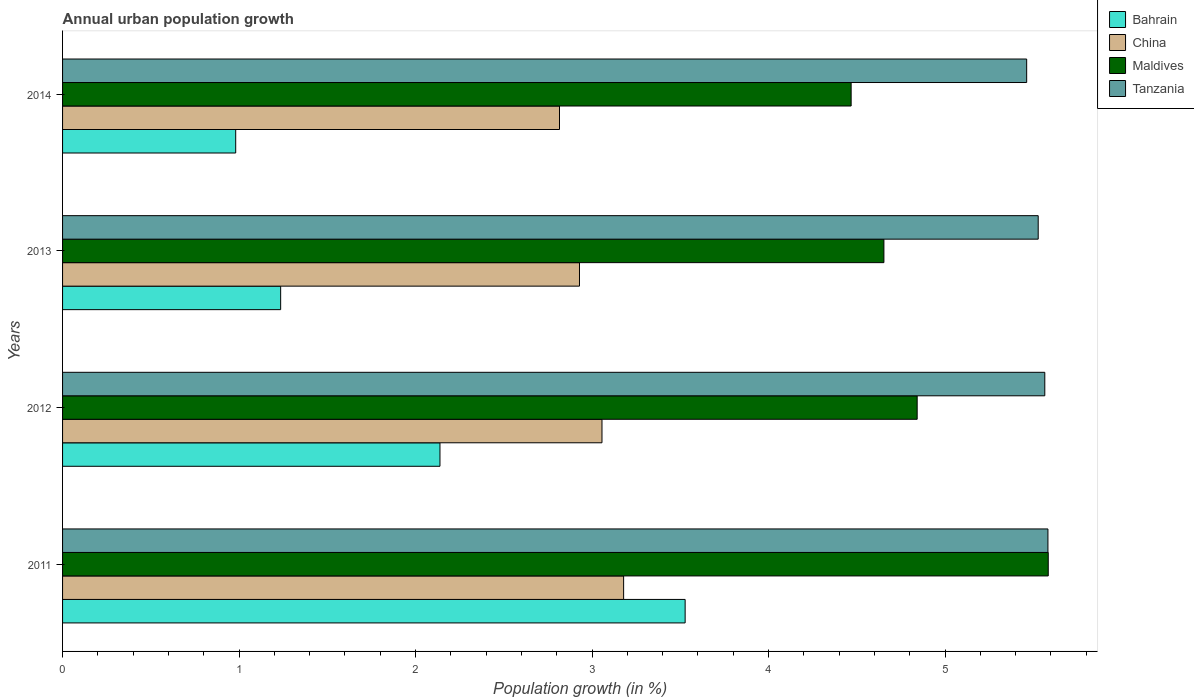Are the number of bars per tick equal to the number of legend labels?
Make the answer very short. Yes. How many bars are there on the 2nd tick from the top?
Ensure brevity in your answer.  4. In how many cases, is the number of bars for a given year not equal to the number of legend labels?
Provide a succinct answer. 0. What is the percentage of urban population growth in Tanzania in 2011?
Offer a terse response. 5.58. Across all years, what is the maximum percentage of urban population growth in Bahrain?
Make the answer very short. 3.53. Across all years, what is the minimum percentage of urban population growth in China?
Your response must be concise. 2.82. In which year was the percentage of urban population growth in Maldives maximum?
Offer a very short reply. 2011. In which year was the percentage of urban population growth in Bahrain minimum?
Provide a succinct answer. 2014. What is the total percentage of urban population growth in Bahrain in the graph?
Your answer should be compact. 7.88. What is the difference between the percentage of urban population growth in Maldives in 2013 and that in 2014?
Offer a very short reply. 0.19. What is the difference between the percentage of urban population growth in Tanzania in 2011 and the percentage of urban population growth in China in 2012?
Ensure brevity in your answer.  2.53. What is the average percentage of urban population growth in China per year?
Your answer should be compact. 2.99. In the year 2014, what is the difference between the percentage of urban population growth in Bahrain and percentage of urban population growth in Maldives?
Keep it short and to the point. -3.49. What is the ratio of the percentage of urban population growth in Maldives in 2013 to that in 2014?
Your answer should be very brief. 1.04. Is the percentage of urban population growth in Bahrain in 2013 less than that in 2014?
Your answer should be very brief. No. What is the difference between the highest and the second highest percentage of urban population growth in China?
Ensure brevity in your answer.  0.12. What is the difference between the highest and the lowest percentage of urban population growth in China?
Provide a succinct answer. 0.36. Is the sum of the percentage of urban population growth in China in 2013 and 2014 greater than the maximum percentage of urban population growth in Bahrain across all years?
Your response must be concise. Yes. What does the 2nd bar from the top in 2012 represents?
Your response must be concise. Maldives. What does the 3rd bar from the bottom in 2011 represents?
Provide a short and direct response. Maldives. How many years are there in the graph?
Keep it short and to the point. 4. What is the difference between two consecutive major ticks on the X-axis?
Your answer should be very brief. 1. Are the values on the major ticks of X-axis written in scientific E-notation?
Provide a succinct answer. No. Does the graph contain grids?
Your answer should be compact. No. Where does the legend appear in the graph?
Offer a very short reply. Top right. How are the legend labels stacked?
Ensure brevity in your answer.  Vertical. What is the title of the graph?
Make the answer very short. Annual urban population growth. Does "Caribbean small states" appear as one of the legend labels in the graph?
Offer a very short reply. No. What is the label or title of the X-axis?
Offer a terse response. Population growth (in %). What is the label or title of the Y-axis?
Your answer should be compact. Years. What is the Population growth (in %) in Bahrain in 2011?
Keep it short and to the point. 3.53. What is the Population growth (in %) in China in 2011?
Keep it short and to the point. 3.18. What is the Population growth (in %) of Maldives in 2011?
Give a very brief answer. 5.58. What is the Population growth (in %) of Tanzania in 2011?
Provide a short and direct response. 5.58. What is the Population growth (in %) of Bahrain in 2012?
Make the answer very short. 2.14. What is the Population growth (in %) in China in 2012?
Provide a succinct answer. 3.06. What is the Population growth (in %) of Maldives in 2012?
Provide a succinct answer. 4.84. What is the Population growth (in %) of Tanzania in 2012?
Your answer should be very brief. 5.56. What is the Population growth (in %) of Bahrain in 2013?
Your response must be concise. 1.24. What is the Population growth (in %) of China in 2013?
Offer a terse response. 2.93. What is the Population growth (in %) of Maldives in 2013?
Ensure brevity in your answer.  4.65. What is the Population growth (in %) in Tanzania in 2013?
Make the answer very short. 5.53. What is the Population growth (in %) in Bahrain in 2014?
Your response must be concise. 0.98. What is the Population growth (in %) in China in 2014?
Your response must be concise. 2.82. What is the Population growth (in %) in Maldives in 2014?
Ensure brevity in your answer.  4.47. What is the Population growth (in %) in Tanzania in 2014?
Make the answer very short. 5.46. Across all years, what is the maximum Population growth (in %) of Bahrain?
Your answer should be compact. 3.53. Across all years, what is the maximum Population growth (in %) in China?
Your answer should be compact. 3.18. Across all years, what is the maximum Population growth (in %) of Maldives?
Make the answer very short. 5.58. Across all years, what is the maximum Population growth (in %) of Tanzania?
Your answer should be very brief. 5.58. Across all years, what is the minimum Population growth (in %) of Bahrain?
Ensure brevity in your answer.  0.98. Across all years, what is the minimum Population growth (in %) in China?
Offer a terse response. 2.82. Across all years, what is the minimum Population growth (in %) of Maldives?
Provide a short and direct response. 4.47. Across all years, what is the minimum Population growth (in %) in Tanzania?
Ensure brevity in your answer.  5.46. What is the total Population growth (in %) in Bahrain in the graph?
Your answer should be very brief. 7.88. What is the total Population growth (in %) of China in the graph?
Your answer should be compact. 11.98. What is the total Population growth (in %) of Maldives in the graph?
Provide a short and direct response. 19.55. What is the total Population growth (in %) of Tanzania in the graph?
Provide a succinct answer. 22.14. What is the difference between the Population growth (in %) of Bahrain in 2011 and that in 2012?
Offer a terse response. 1.39. What is the difference between the Population growth (in %) in China in 2011 and that in 2012?
Provide a succinct answer. 0.12. What is the difference between the Population growth (in %) of Maldives in 2011 and that in 2012?
Your response must be concise. 0.74. What is the difference between the Population growth (in %) in Tanzania in 2011 and that in 2012?
Provide a short and direct response. 0.02. What is the difference between the Population growth (in %) in Bahrain in 2011 and that in 2013?
Provide a short and direct response. 2.29. What is the difference between the Population growth (in %) of Maldives in 2011 and that in 2013?
Your answer should be compact. 0.93. What is the difference between the Population growth (in %) in Tanzania in 2011 and that in 2013?
Your response must be concise. 0.06. What is the difference between the Population growth (in %) of Bahrain in 2011 and that in 2014?
Provide a short and direct response. 2.55. What is the difference between the Population growth (in %) of China in 2011 and that in 2014?
Offer a very short reply. 0.36. What is the difference between the Population growth (in %) of Maldives in 2011 and that in 2014?
Keep it short and to the point. 1.12. What is the difference between the Population growth (in %) of Tanzania in 2011 and that in 2014?
Provide a short and direct response. 0.12. What is the difference between the Population growth (in %) of Bahrain in 2012 and that in 2013?
Your answer should be compact. 0.9. What is the difference between the Population growth (in %) of China in 2012 and that in 2013?
Offer a very short reply. 0.13. What is the difference between the Population growth (in %) in Maldives in 2012 and that in 2013?
Offer a terse response. 0.19. What is the difference between the Population growth (in %) of Tanzania in 2012 and that in 2013?
Your response must be concise. 0.04. What is the difference between the Population growth (in %) in Bahrain in 2012 and that in 2014?
Offer a very short reply. 1.16. What is the difference between the Population growth (in %) in China in 2012 and that in 2014?
Ensure brevity in your answer.  0.24. What is the difference between the Population growth (in %) of Maldives in 2012 and that in 2014?
Give a very brief answer. 0.37. What is the difference between the Population growth (in %) of Tanzania in 2012 and that in 2014?
Offer a terse response. 0.1. What is the difference between the Population growth (in %) in Bahrain in 2013 and that in 2014?
Your response must be concise. 0.25. What is the difference between the Population growth (in %) of China in 2013 and that in 2014?
Give a very brief answer. 0.11. What is the difference between the Population growth (in %) of Maldives in 2013 and that in 2014?
Your response must be concise. 0.19. What is the difference between the Population growth (in %) of Tanzania in 2013 and that in 2014?
Offer a terse response. 0.07. What is the difference between the Population growth (in %) in Bahrain in 2011 and the Population growth (in %) in China in 2012?
Offer a very short reply. 0.47. What is the difference between the Population growth (in %) in Bahrain in 2011 and the Population growth (in %) in Maldives in 2012?
Ensure brevity in your answer.  -1.31. What is the difference between the Population growth (in %) of Bahrain in 2011 and the Population growth (in %) of Tanzania in 2012?
Offer a very short reply. -2.04. What is the difference between the Population growth (in %) of China in 2011 and the Population growth (in %) of Maldives in 2012?
Your answer should be very brief. -1.66. What is the difference between the Population growth (in %) of China in 2011 and the Population growth (in %) of Tanzania in 2012?
Your answer should be compact. -2.39. What is the difference between the Population growth (in %) in Maldives in 2011 and the Population growth (in %) in Tanzania in 2012?
Give a very brief answer. 0.02. What is the difference between the Population growth (in %) in Bahrain in 2011 and the Population growth (in %) in China in 2013?
Ensure brevity in your answer.  0.6. What is the difference between the Population growth (in %) of Bahrain in 2011 and the Population growth (in %) of Maldives in 2013?
Your response must be concise. -1.13. What is the difference between the Population growth (in %) of Bahrain in 2011 and the Population growth (in %) of Tanzania in 2013?
Your answer should be very brief. -2. What is the difference between the Population growth (in %) in China in 2011 and the Population growth (in %) in Maldives in 2013?
Keep it short and to the point. -1.47. What is the difference between the Population growth (in %) of China in 2011 and the Population growth (in %) of Tanzania in 2013?
Give a very brief answer. -2.35. What is the difference between the Population growth (in %) in Maldives in 2011 and the Population growth (in %) in Tanzania in 2013?
Your response must be concise. 0.06. What is the difference between the Population growth (in %) in Bahrain in 2011 and the Population growth (in %) in China in 2014?
Give a very brief answer. 0.71. What is the difference between the Population growth (in %) of Bahrain in 2011 and the Population growth (in %) of Maldives in 2014?
Offer a very short reply. -0.94. What is the difference between the Population growth (in %) in Bahrain in 2011 and the Population growth (in %) in Tanzania in 2014?
Your answer should be compact. -1.93. What is the difference between the Population growth (in %) in China in 2011 and the Population growth (in %) in Maldives in 2014?
Offer a very short reply. -1.29. What is the difference between the Population growth (in %) of China in 2011 and the Population growth (in %) of Tanzania in 2014?
Keep it short and to the point. -2.28. What is the difference between the Population growth (in %) of Maldives in 2011 and the Population growth (in %) of Tanzania in 2014?
Offer a very short reply. 0.12. What is the difference between the Population growth (in %) of Bahrain in 2012 and the Population growth (in %) of China in 2013?
Keep it short and to the point. -0.79. What is the difference between the Population growth (in %) in Bahrain in 2012 and the Population growth (in %) in Maldives in 2013?
Offer a terse response. -2.52. What is the difference between the Population growth (in %) of Bahrain in 2012 and the Population growth (in %) of Tanzania in 2013?
Give a very brief answer. -3.39. What is the difference between the Population growth (in %) of China in 2012 and the Population growth (in %) of Maldives in 2013?
Provide a short and direct response. -1.6. What is the difference between the Population growth (in %) of China in 2012 and the Population growth (in %) of Tanzania in 2013?
Provide a succinct answer. -2.47. What is the difference between the Population growth (in %) in Maldives in 2012 and the Population growth (in %) in Tanzania in 2013?
Offer a very short reply. -0.69. What is the difference between the Population growth (in %) in Bahrain in 2012 and the Population growth (in %) in China in 2014?
Give a very brief answer. -0.68. What is the difference between the Population growth (in %) of Bahrain in 2012 and the Population growth (in %) of Maldives in 2014?
Keep it short and to the point. -2.33. What is the difference between the Population growth (in %) in Bahrain in 2012 and the Population growth (in %) in Tanzania in 2014?
Make the answer very short. -3.32. What is the difference between the Population growth (in %) in China in 2012 and the Population growth (in %) in Maldives in 2014?
Ensure brevity in your answer.  -1.41. What is the difference between the Population growth (in %) in China in 2012 and the Population growth (in %) in Tanzania in 2014?
Offer a terse response. -2.41. What is the difference between the Population growth (in %) of Maldives in 2012 and the Population growth (in %) of Tanzania in 2014?
Your response must be concise. -0.62. What is the difference between the Population growth (in %) in Bahrain in 2013 and the Population growth (in %) in China in 2014?
Keep it short and to the point. -1.58. What is the difference between the Population growth (in %) of Bahrain in 2013 and the Population growth (in %) of Maldives in 2014?
Provide a short and direct response. -3.23. What is the difference between the Population growth (in %) in Bahrain in 2013 and the Population growth (in %) in Tanzania in 2014?
Offer a terse response. -4.23. What is the difference between the Population growth (in %) of China in 2013 and the Population growth (in %) of Maldives in 2014?
Your answer should be very brief. -1.54. What is the difference between the Population growth (in %) of China in 2013 and the Population growth (in %) of Tanzania in 2014?
Provide a succinct answer. -2.53. What is the difference between the Population growth (in %) of Maldives in 2013 and the Population growth (in %) of Tanzania in 2014?
Offer a very short reply. -0.81. What is the average Population growth (in %) of Bahrain per year?
Provide a short and direct response. 1.97. What is the average Population growth (in %) of China per year?
Your response must be concise. 2.99. What is the average Population growth (in %) in Maldives per year?
Your response must be concise. 4.89. What is the average Population growth (in %) of Tanzania per year?
Offer a very short reply. 5.53. In the year 2011, what is the difference between the Population growth (in %) of Bahrain and Population growth (in %) of China?
Your answer should be very brief. 0.35. In the year 2011, what is the difference between the Population growth (in %) of Bahrain and Population growth (in %) of Maldives?
Offer a terse response. -2.06. In the year 2011, what is the difference between the Population growth (in %) in Bahrain and Population growth (in %) in Tanzania?
Ensure brevity in your answer.  -2.06. In the year 2011, what is the difference between the Population growth (in %) in China and Population growth (in %) in Maldives?
Provide a short and direct response. -2.41. In the year 2011, what is the difference between the Population growth (in %) in China and Population growth (in %) in Tanzania?
Give a very brief answer. -2.4. In the year 2011, what is the difference between the Population growth (in %) of Maldives and Population growth (in %) of Tanzania?
Offer a terse response. 0. In the year 2012, what is the difference between the Population growth (in %) of Bahrain and Population growth (in %) of China?
Offer a very short reply. -0.92. In the year 2012, what is the difference between the Population growth (in %) in Bahrain and Population growth (in %) in Maldives?
Make the answer very short. -2.7. In the year 2012, what is the difference between the Population growth (in %) in Bahrain and Population growth (in %) in Tanzania?
Your answer should be compact. -3.43. In the year 2012, what is the difference between the Population growth (in %) of China and Population growth (in %) of Maldives?
Offer a terse response. -1.79. In the year 2012, what is the difference between the Population growth (in %) in China and Population growth (in %) in Tanzania?
Your response must be concise. -2.51. In the year 2012, what is the difference between the Population growth (in %) of Maldives and Population growth (in %) of Tanzania?
Make the answer very short. -0.72. In the year 2013, what is the difference between the Population growth (in %) of Bahrain and Population growth (in %) of China?
Provide a succinct answer. -1.69. In the year 2013, what is the difference between the Population growth (in %) in Bahrain and Population growth (in %) in Maldives?
Your response must be concise. -3.42. In the year 2013, what is the difference between the Population growth (in %) of Bahrain and Population growth (in %) of Tanzania?
Offer a very short reply. -4.29. In the year 2013, what is the difference between the Population growth (in %) in China and Population growth (in %) in Maldives?
Your answer should be very brief. -1.72. In the year 2013, what is the difference between the Population growth (in %) in China and Population growth (in %) in Tanzania?
Your answer should be very brief. -2.6. In the year 2013, what is the difference between the Population growth (in %) of Maldives and Population growth (in %) of Tanzania?
Make the answer very short. -0.87. In the year 2014, what is the difference between the Population growth (in %) of Bahrain and Population growth (in %) of China?
Offer a very short reply. -1.83. In the year 2014, what is the difference between the Population growth (in %) in Bahrain and Population growth (in %) in Maldives?
Offer a terse response. -3.49. In the year 2014, what is the difference between the Population growth (in %) of Bahrain and Population growth (in %) of Tanzania?
Ensure brevity in your answer.  -4.48. In the year 2014, what is the difference between the Population growth (in %) of China and Population growth (in %) of Maldives?
Your answer should be compact. -1.65. In the year 2014, what is the difference between the Population growth (in %) of China and Population growth (in %) of Tanzania?
Your answer should be very brief. -2.65. In the year 2014, what is the difference between the Population growth (in %) in Maldives and Population growth (in %) in Tanzania?
Provide a succinct answer. -0.99. What is the ratio of the Population growth (in %) of Bahrain in 2011 to that in 2012?
Keep it short and to the point. 1.65. What is the ratio of the Population growth (in %) in China in 2011 to that in 2012?
Give a very brief answer. 1.04. What is the ratio of the Population growth (in %) in Maldives in 2011 to that in 2012?
Your response must be concise. 1.15. What is the ratio of the Population growth (in %) of Tanzania in 2011 to that in 2012?
Offer a very short reply. 1. What is the ratio of the Population growth (in %) of Bahrain in 2011 to that in 2013?
Your response must be concise. 2.85. What is the ratio of the Population growth (in %) of China in 2011 to that in 2013?
Offer a terse response. 1.09. What is the ratio of the Population growth (in %) in Maldives in 2011 to that in 2013?
Give a very brief answer. 1.2. What is the ratio of the Population growth (in %) in Tanzania in 2011 to that in 2013?
Offer a terse response. 1.01. What is the ratio of the Population growth (in %) of Bahrain in 2011 to that in 2014?
Your answer should be compact. 3.6. What is the ratio of the Population growth (in %) of China in 2011 to that in 2014?
Ensure brevity in your answer.  1.13. What is the ratio of the Population growth (in %) in Tanzania in 2011 to that in 2014?
Offer a very short reply. 1.02. What is the ratio of the Population growth (in %) in Bahrain in 2012 to that in 2013?
Provide a short and direct response. 1.73. What is the ratio of the Population growth (in %) of China in 2012 to that in 2013?
Ensure brevity in your answer.  1.04. What is the ratio of the Population growth (in %) of Maldives in 2012 to that in 2013?
Offer a very short reply. 1.04. What is the ratio of the Population growth (in %) in Tanzania in 2012 to that in 2013?
Your answer should be very brief. 1.01. What is the ratio of the Population growth (in %) of Bahrain in 2012 to that in 2014?
Keep it short and to the point. 2.18. What is the ratio of the Population growth (in %) in China in 2012 to that in 2014?
Offer a very short reply. 1.09. What is the ratio of the Population growth (in %) in Maldives in 2012 to that in 2014?
Provide a succinct answer. 1.08. What is the ratio of the Population growth (in %) in Tanzania in 2012 to that in 2014?
Give a very brief answer. 1.02. What is the ratio of the Population growth (in %) in Bahrain in 2013 to that in 2014?
Give a very brief answer. 1.26. What is the ratio of the Population growth (in %) in China in 2013 to that in 2014?
Your answer should be very brief. 1.04. What is the ratio of the Population growth (in %) in Maldives in 2013 to that in 2014?
Offer a very short reply. 1.04. What is the ratio of the Population growth (in %) in Tanzania in 2013 to that in 2014?
Provide a short and direct response. 1.01. What is the difference between the highest and the second highest Population growth (in %) in Bahrain?
Make the answer very short. 1.39. What is the difference between the highest and the second highest Population growth (in %) in China?
Keep it short and to the point. 0.12. What is the difference between the highest and the second highest Population growth (in %) in Maldives?
Offer a very short reply. 0.74. What is the difference between the highest and the second highest Population growth (in %) of Tanzania?
Offer a terse response. 0.02. What is the difference between the highest and the lowest Population growth (in %) of Bahrain?
Give a very brief answer. 2.55. What is the difference between the highest and the lowest Population growth (in %) in China?
Provide a succinct answer. 0.36. What is the difference between the highest and the lowest Population growth (in %) of Maldives?
Your response must be concise. 1.12. What is the difference between the highest and the lowest Population growth (in %) of Tanzania?
Offer a terse response. 0.12. 